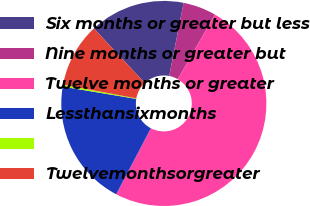<chart> <loc_0><loc_0><loc_500><loc_500><pie_chart><fcel>Six months or greater but less<fcel>Nine months or greater but<fcel>Twelve months or greater<fcel>Lessthansixmonths<fcel>Unnamed: 4<fcel>Twelvemonthsorgreater<nl><fcel>15.03%<fcel>5.22%<fcel>49.38%<fcel>19.94%<fcel>0.31%<fcel>10.12%<nl></chart> 